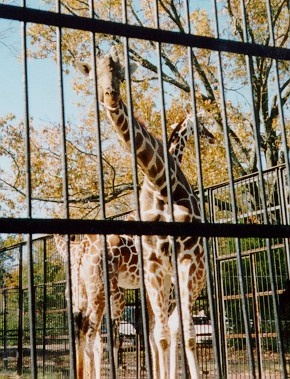Describe the objects in this image and their specific colors. I can see giraffe in lightblue, black, lightgray, and tan tones, giraffe in lightblue, tan, black, and lightgray tones, and giraffe in lightblue, lightgray, tan, and gray tones in this image. 